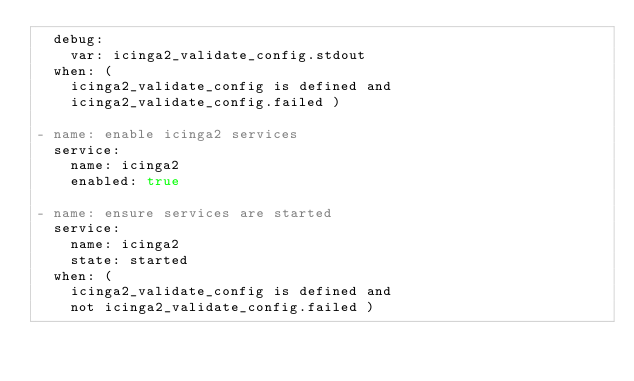<code> <loc_0><loc_0><loc_500><loc_500><_YAML_>  debug:
    var: icinga2_validate_config.stdout
  when: (
    icinga2_validate_config is defined and
    icinga2_validate_config.failed )

- name: enable icinga2 services
  service:
    name: icinga2
    enabled: true

- name: ensure services are started
  service:
    name: icinga2
    state: started
  when: (
    icinga2_validate_config is defined and
    not icinga2_validate_config.failed )
</code> 